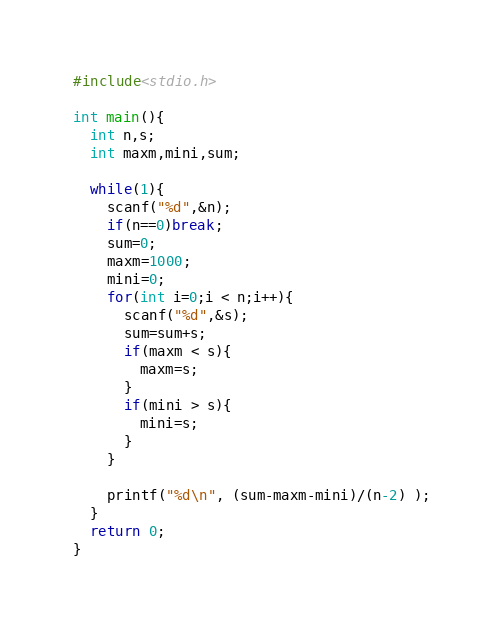<code> <loc_0><loc_0><loc_500><loc_500><_C++_>#include<stdio.h>

int main(){
  int n,s;
  int maxm,mini,sum;
  
  while(1){
    scanf("%d",&n);
    if(n==0)break;
    sum=0;
    maxm=1000;
    mini=0;
    for(int i=0;i < n;i++){
      scanf("%d",&s);
      sum=sum+s;
      if(maxm < s){
        maxm=s;
      }
      if(mini > s){
        mini=s;
      }
    }

    printf("%d\n", (sum-maxm-mini)/(n-2) );
  }
  return 0;
}</code> 